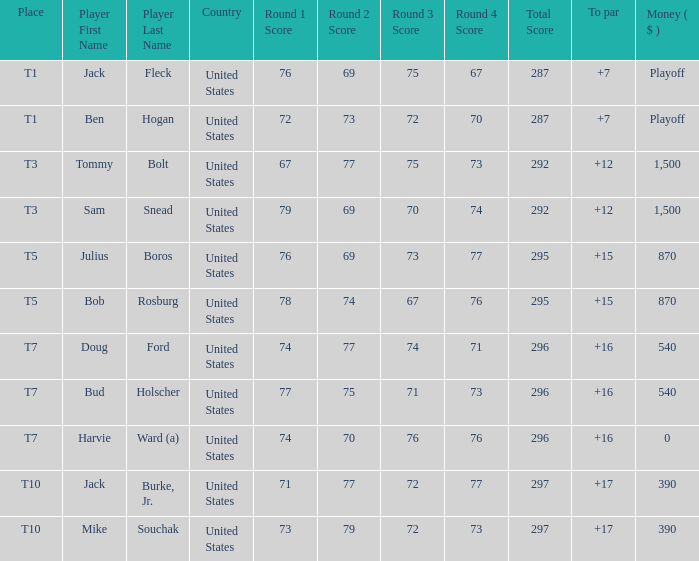What is average to par when Bud Holscher is the player? 16.0. 